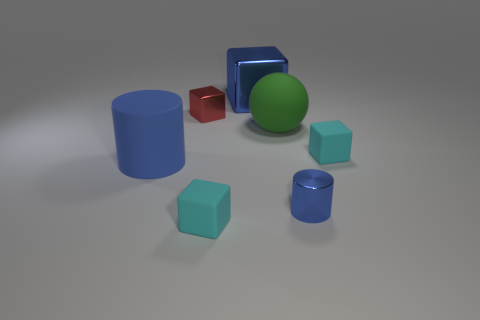Subtract all small metallic cubes. How many cubes are left? 3 Subtract all blue cubes. How many cubes are left? 3 Subtract all yellow cubes. Subtract all red spheres. How many cubes are left? 4 Add 2 large cyan shiny blocks. How many objects exist? 9 Subtract 2 blue cylinders. How many objects are left? 5 Subtract all cylinders. How many objects are left? 5 Subtract all large blue metal things. Subtract all tiny brown rubber objects. How many objects are left? 6 Add 5 blue metallic cubes. How many blue metallic cubes are left? 6 Add 7 red rubber things. How many red rubber things exist? 7 